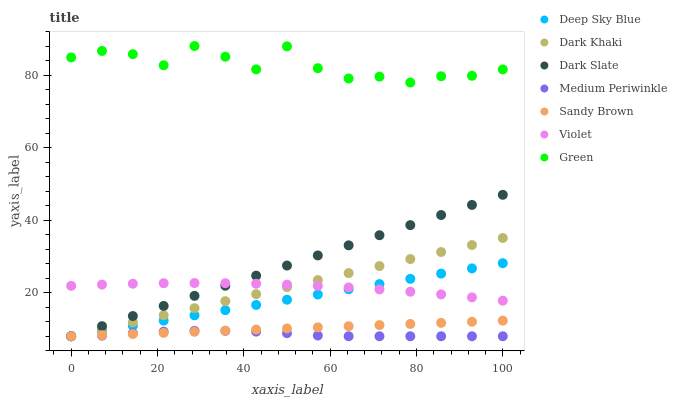Does Medium Periwinkle have the minimum area under the curve?
Answer yes or no. Yes. Does Green have the maximum area under the curve?
Answer yes or no. Yes. Does Dark Khaki have the minimum area under the curve?
Answer yes or no. No. Does Dark Khaki have the maximum area under the curve?
Answer yes or no. No. Is Sandy Brown the smoothest?
Answer yes or no. Yes. Is Green the roughest?
Answer yes or no. Yes. Is Dark Khaki the smoothest?
Answer yes or no. No. Is Dark Khaki the roughest?
Answer yes or no. No. Does Medium Periwinkle have the lowest value?
Answer yes or no. Yes. Does Green have the lowest value?
Answer yes or no. No. Does Green have the highest value?
Answer yes or no. Yes. Does Dark Khaki have the highest value?
Answer yes or no. No. Is Sandy Brown less than Violet?
Answer yes or no. Yes. Is Violet greater than Sandy Brown?
Answer yes or no. Yes. Does Dark Khaki intersect Sandy Brown?
Answer yes or no. Yes. Is Dark Khaki less than Sandy Brown?
Answer yes or no. No. Is Dark Khaki greater than Sandy Brown?
Answer yes or no. No. Does Sandy Brown intersect Violet?
Answer yes or no. No. 